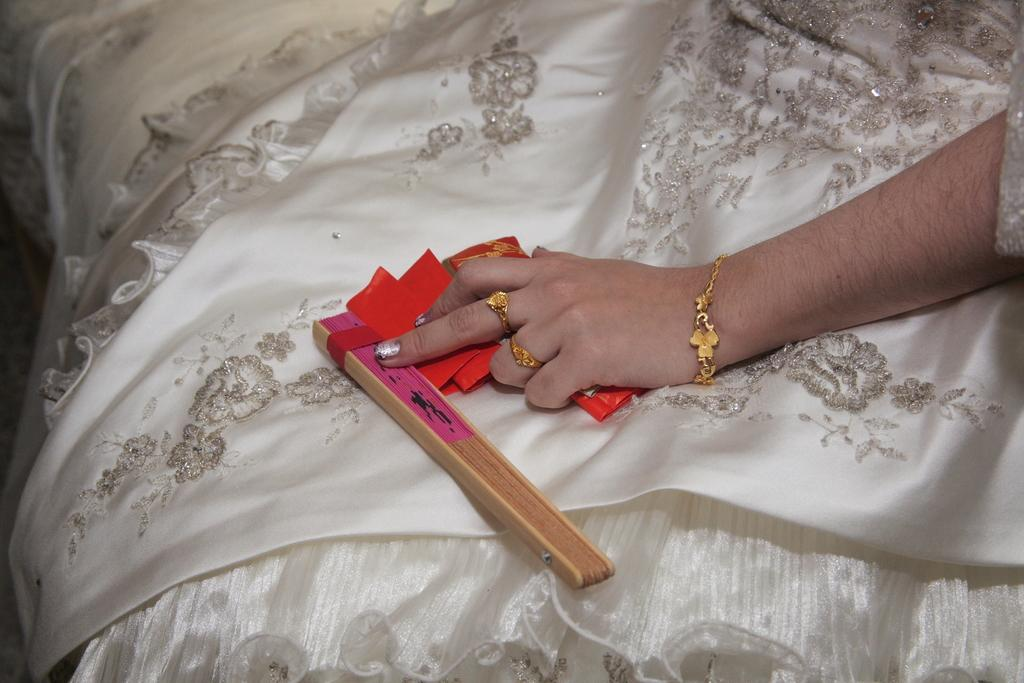What object made of wood can be seen in the image? There is a wooden stick in the image. What is the woman holding in her hand? There are papers in the woman's hand. What type of jewelry is visible in the image? There are rings and a bracelet visible in the image. Can you describe the woman's attire in the image? The woman is wearing a white dress with a design on it. What does the mailbox look like in the image? There is no mailbox present in the image. How many teeth can be seen in the woman's mouth in the image? The image does not show the woman's mouth, so it is not possible to determine how many teeth she has. 